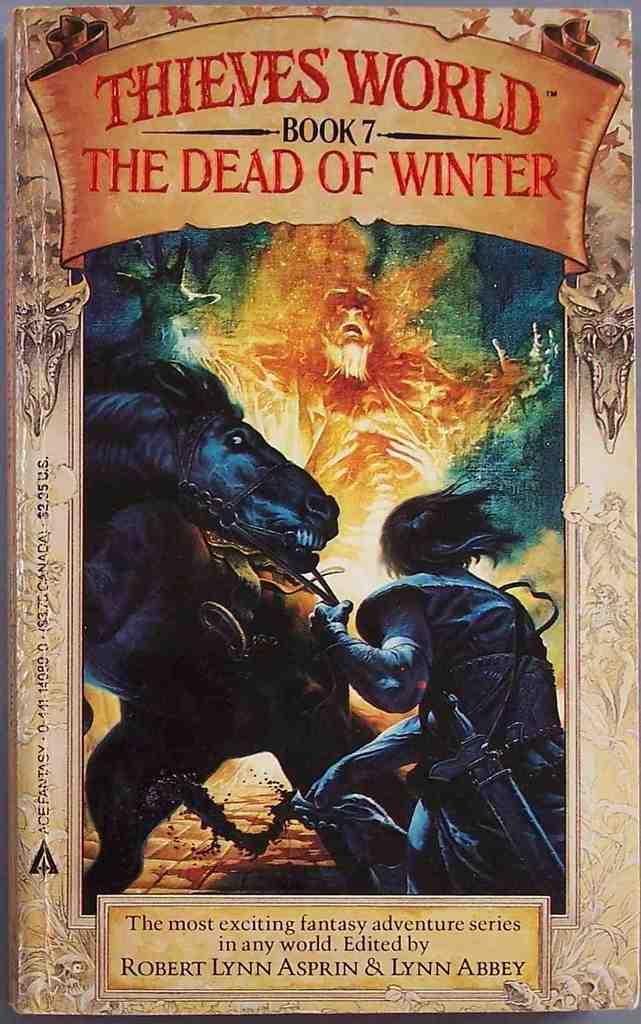What season is mentioned with this book?
Your response must be concise. Winter. What book number is this in the series?
Offer a very short reply. 7. 